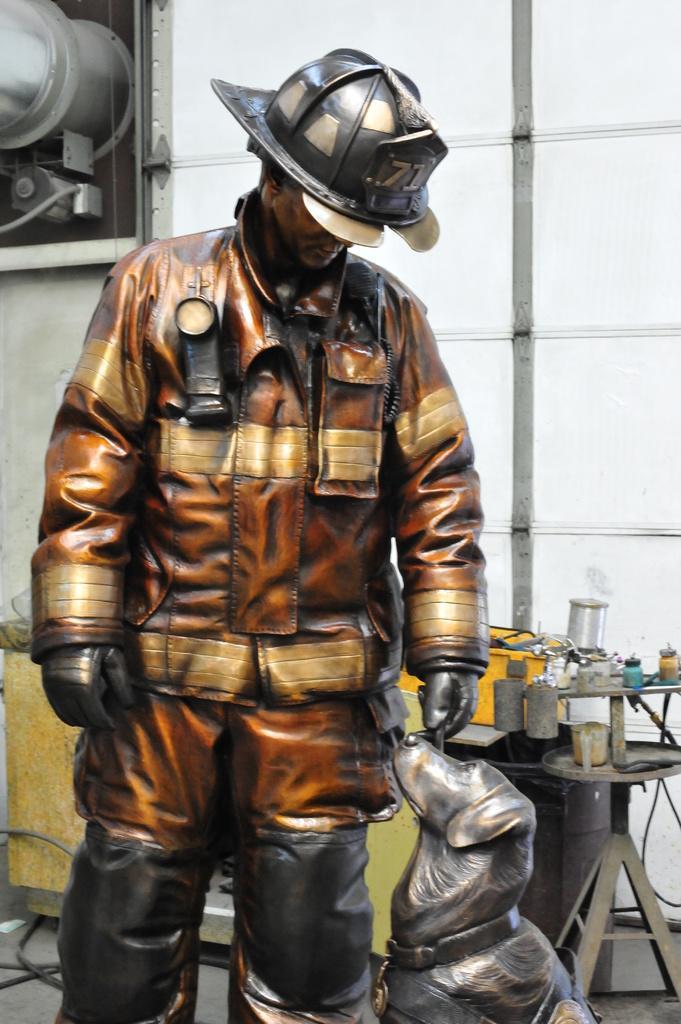How would you summarize this image in a sentence or two? In this image we can see a statue. In the background there is a table and we can see things placed on the table and there is a wall. We can see a frame placed on the wall. 